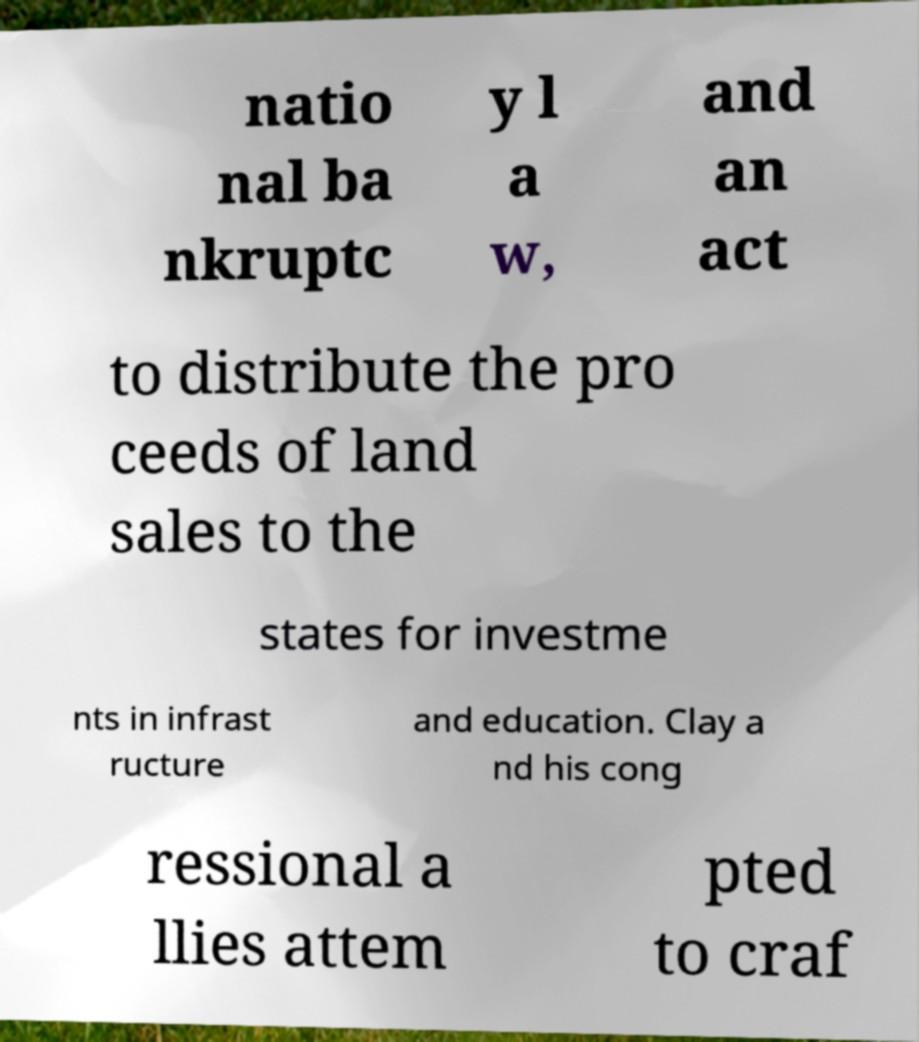Please identify and transcribe the text found in this image. natio nal ba nkruptc y l a w, and an act to distribute the pro ceeds of land sales to the states for investme nts in infrast ructure and education. Clay a nd his cong ressional a llies attem pted to craf 